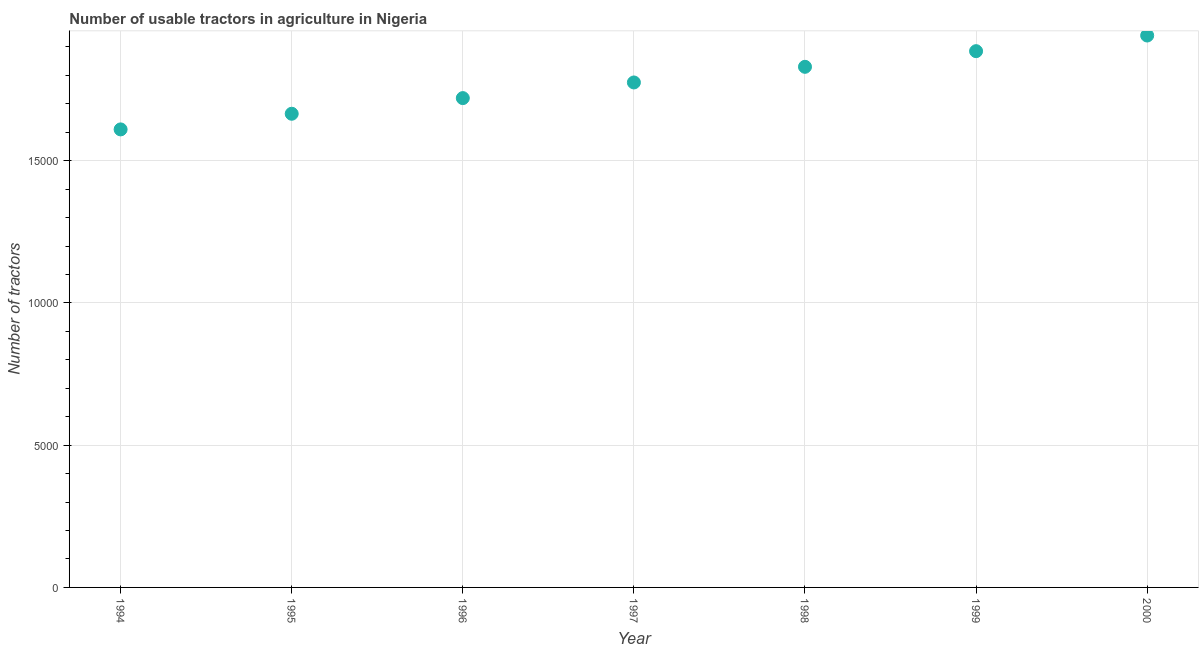What is the number of tractors in 1996?
Ensure brevity in your answer.  1.72e+04. Across all years, what is the maximum number of tractors?
Your response must be concise. 1.94e+04. Across all years, what is the minimum number of tractors?
Provide a succinct answer. 1.61e+04. In which year was the number of tractors maximum?
Offer a terse response. 2000. What is the sum of the number of tractors?
Ensure brevity in your answer.  1.24e+05. What is the difference between the number of tractors in 1995 and 2000?
Offer a terse response. -2750. What is the average number of tractors per year?
Make the answer very short. 1.78e+04. What is the median number of tractors?
Provide a succinct answer. 1.78e+04. Do a majority of the years between 1995 and 1998 (inclusive) have number of tractors greater than 3000 ?
Your answer should be very brief. Yes. What is the ratio of the number of tractors in 1994 to that in 1995?
Offer a terse response. 0.97. What is the difference between the highest and the second highest number of tractors?
Ensure brevity in your answer.  550. What is the difference between the highest and the lowest number of tractors?
Make the answer very short. 3300. Does the number of tractors monotonically increase over the years?
Offer a very short reply. Yes. What is the difference between two consecutive major ticks on the Y-axis?
Offer a terse response. 5000. What is the title of the graph?
Make the answer very short. Number of usable tractors in agriculture in Nigeria. What is the label or title of the X-axis?
Offer a very short reply. Year. What is the label or title of the Y-axis?
Ensure brevity in your answer.  Number of tractors. What is the Number of tractors in 1994?
Give a very brief answer. 1.61e+04. What is the Number of tractors in 1995?
Provide a succinct answer. 1.66e+04. What is the Number of tractors in 1996?
Offer a very short reply. 1.72e+04. What is the Number of tractors in 1997?
Offer a very short reply. 1.78e+04. What is the Number of tractors in 1998?
Your answer should be compact. 1.83e+04. What is the Number of tractors in 1999?
Your answer should be compact. 1.88e+04. What is the Number of tractors in 2000?
Give a very brief answer. 1.94e+04. What is the difference between the Number of tractors in 1994 and 1995?
Ensure brevity in your answer.  -550. What is the difference between the Number of tractors in 1994 and 1996?
Your answer should be very brief. -1100. What is the difference between the Number of tractors in 1994 and 1997?
Ensure brevity in your answer.  -1650. What is the difference between the Number of tractors in 1994 and 1998?
Offer a very short reply. -2200. What is the difference between the Number of tractors in 1994 and 1999?
Offer a terse response. -2750. What is the difference between the Number of tractors in 1994 and 2000?
Your answer should be compact. -3300. What is the difference between the Number of tractors in 1995 and 1996?
Offer a very short reply. -550. What is the difference between the Number of tractors in 1995 and 1997?
Keep it short and to the point. -1100. What is the difference between the Number of tractors in 1995 and 1998?
Your answer should be compact. -1650. What is the difference between the Number of tractors in 1995 and 1999?
Make the answer very short. -2200. What is the difference between the Number of tractors in 1995 and 2000?
Give a very brief answer. -2750. What is the difference between the Number of tractors in 1996 and 1997?
Your response must be concise. -550. What is the difference between the Number of tractors in 1996 and 1998?
Provide a short and direct response. -1100. What is the difference between the Number of tractors in 1996 and 1999?
Make the answer very short. -1650. What is the difference between the Number of tractors in 1996 and 2000?
Keep it short and to the point. -2200. What is the difference between the Number of tractors in 1997 and 1998?
Give a very brief answer. -550. What is the difference between the Number of tractors in 1997 and 1999?
Offer a very short reply. -1100. What is the difference between the Number of tractors in 1997 and 2000?
Provide a short and direct response. -1650. What is the difference between the Number of tractors in 1998 and 1999?
Offer a terse response. -550. What is the difference between the Number of tractors in 1998 and 2000?
Make the answer very short. -1100. What is the difference between the Number of tractors in 1999 and 2000?
Offer a terse response. -550. What is the ratio of the Number of tractors in 1994 to that in 1995?
Ensure brevity in your answer.  0.97. What is the ratio of the Number of tractors in 1994 to that in 1996?
Your response must be concise. 0.94. What is the ratio of the Number of tractors in 1994 to that in 1997?
Provide a succinct answer. 0.91. What is the ratio of the Number of tractors in 1994 to that in 1999?
Your answer should be compact. 0.85. What is the ratio of the Number of tractors in 1994 to that in 2000?
Provide a succinct answer. 0.83. What is the ratio of the Number of tractors in 1995 to that in 1997?
Your answer should be compact. 0.94. What is the ratio of the Number of tractors in 1995 to that in 1998?
Give a very brief answer. 0.91. What is the ratio of the Number of tractors in 1995 to that in 1999?
Make the answer very short. 0.88. What is the ratio of the Number of tractors in 1995 to that in 2000?
Your response must be concise. 0.86. What is the ratio of the Number of tractors in 1996 to that in 1999?
Provide a succinct answer. 0.91. What is the ratio of the Number of tractors in 1996 to that in 2000?
Make the answer very short. 0.89. What is the ratio of the Number of tractors in 1997 to that in 1999?
Your answer should be very brief. 0.94. What is the ratio of the Number of tractors in 1997 to that in 2000?
Your answer should be very brief. 0.92. What is the ratio of the Number of tractors in 1998 to that in 1999?
Offer a very short reply. 0.97. What is the ratio of the Number of tractors in 1998 to that in 2000?
Offer a very short reply. 0.94. What is the ratio of the Number of tractors in 1999 to that in 2000?
Your answer should be very brief. 0.97. 